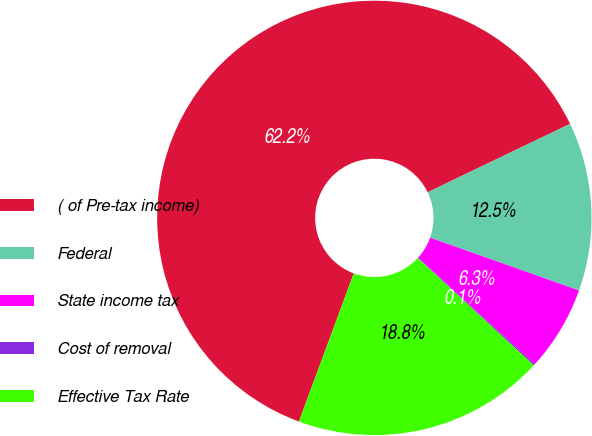<chart> <loc_0><loc_0><loc_500><loc_500><pie_chart><fcel>( of Pre-tax income)<fcel>Federal<fcel>State income tax<fcel>Cost of removal<fcel>Effective Tax Rate<nl><fcel>62.24%<fcel>12.55%<fcel>6.34%<fcel>0.12%<fcel>18.76%<nl></chart> 